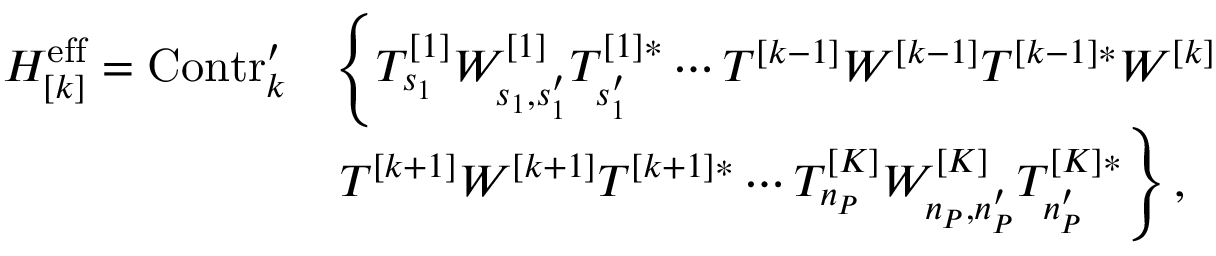<formula> <loc_0><loc_0><loc_500><loc_500>\begin{array} { r l } { H _ { [ k ] } ^ { e f f } = C o n t r _ { k } ^ { \prime } } & { \left \{ T _ { s _ { 1 } } ^ { [ 1 ] } W _ { s _ { 1 } , s _ { 1 } ^ { \prime } } ^ { [ 1 ] } T _ { s _ { 1 } ^ { \prime } } ^ { [ 1 ] * } \cdots T ^ { [ k - 1 ] } W ^ { [ k - 1 ] } T ^ { [ k - 1 ] * } W ^ { [ k ] } } \\ & { T ^ { [ k + 1 ] } W ^ { [ k + 1 ] } T ^ { [ k + 1 ] * } \cdots T _ { n _ { P } } ^ { [ K ] } W _ { n _ { P } , n _ { P } ^ { \prime } } ^ { [ K ] } T _ { n _ { P } ^ { \prime } } ^ { [ K ] * } \right \} , } \end{array}</formula> 